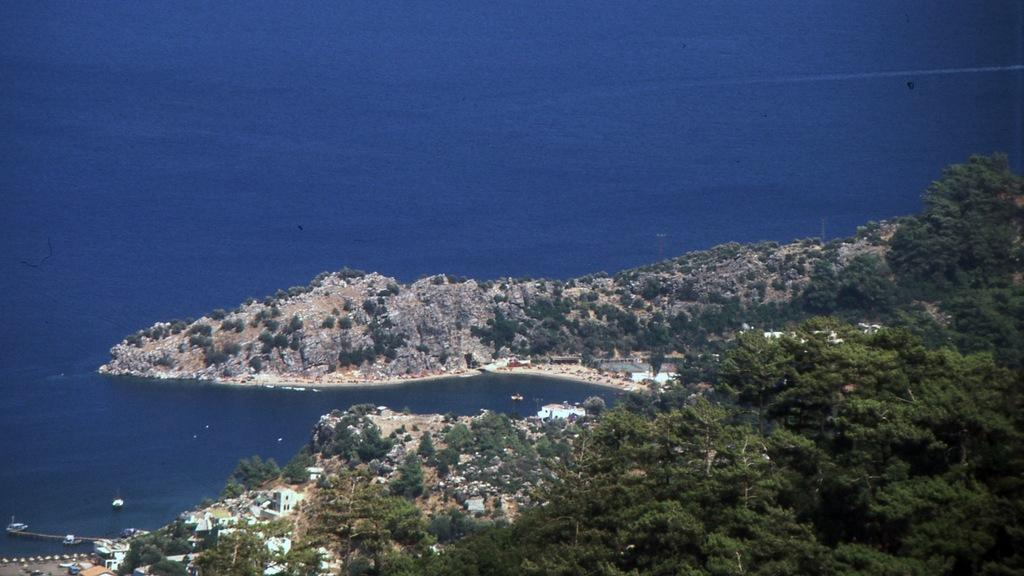What is the main subject of the image? The image shows an aerial view of an island. What type of vegetation can be seen on the island? There are trees and plants on the island. What is visible on the surface of the island? The rock's surface is visible on the island. What color is the water surrounding the island? The water surrounding the island is blue in color. Can you see any arms reaching out of the water in the image? There are no arms visible in the image; it shows an aerial view of an island with blue water surrounding it. 